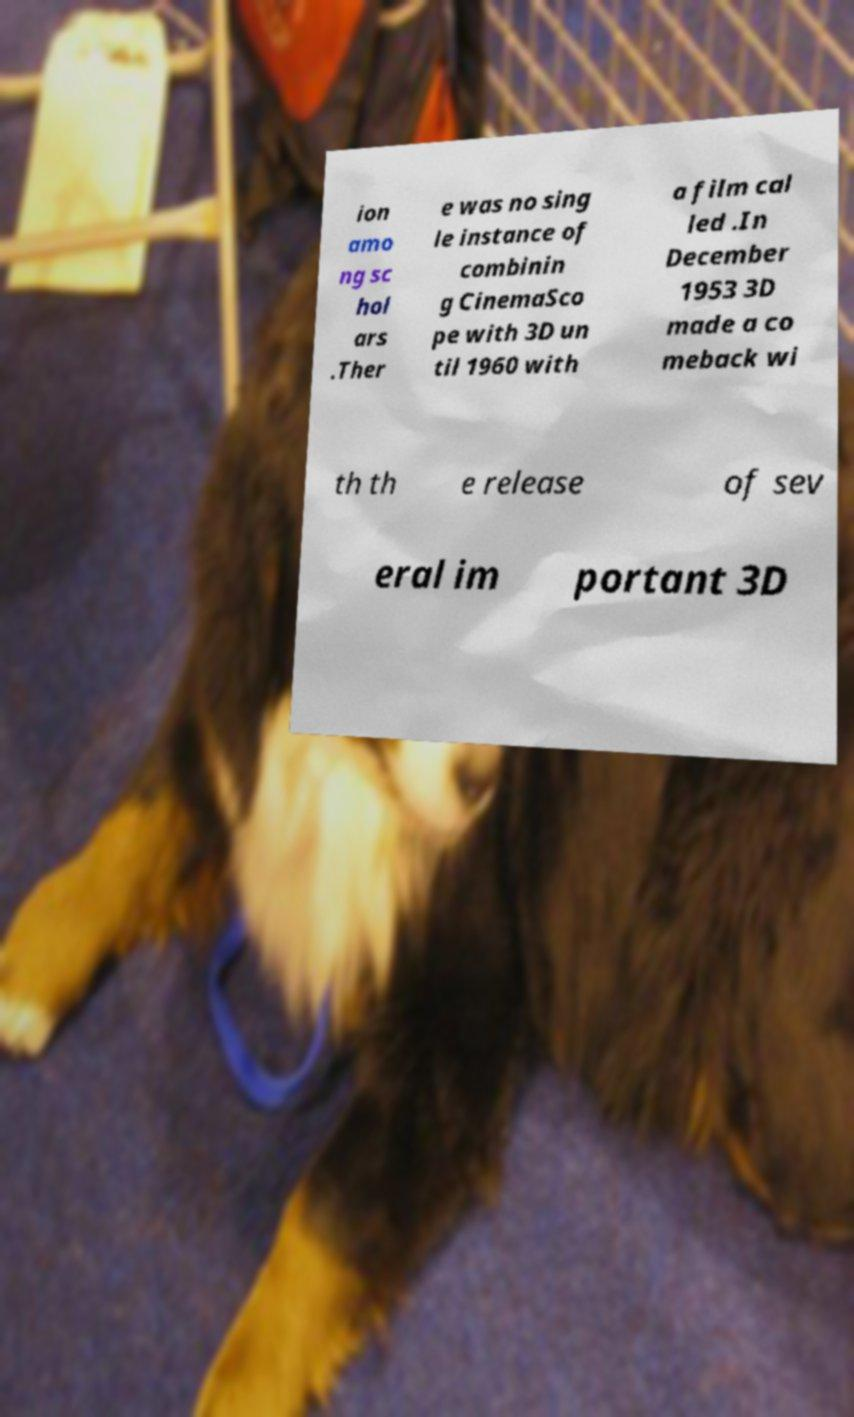Could you extract and type out the text from this image? ion amo ng sc hol ars .Ther e was no sing le instance of combinin g CinemaSco pe with 3D un til 1960 with a film cal led .In December 1953 3D made a co meback wi th th e release of sev eral im portant 3D 